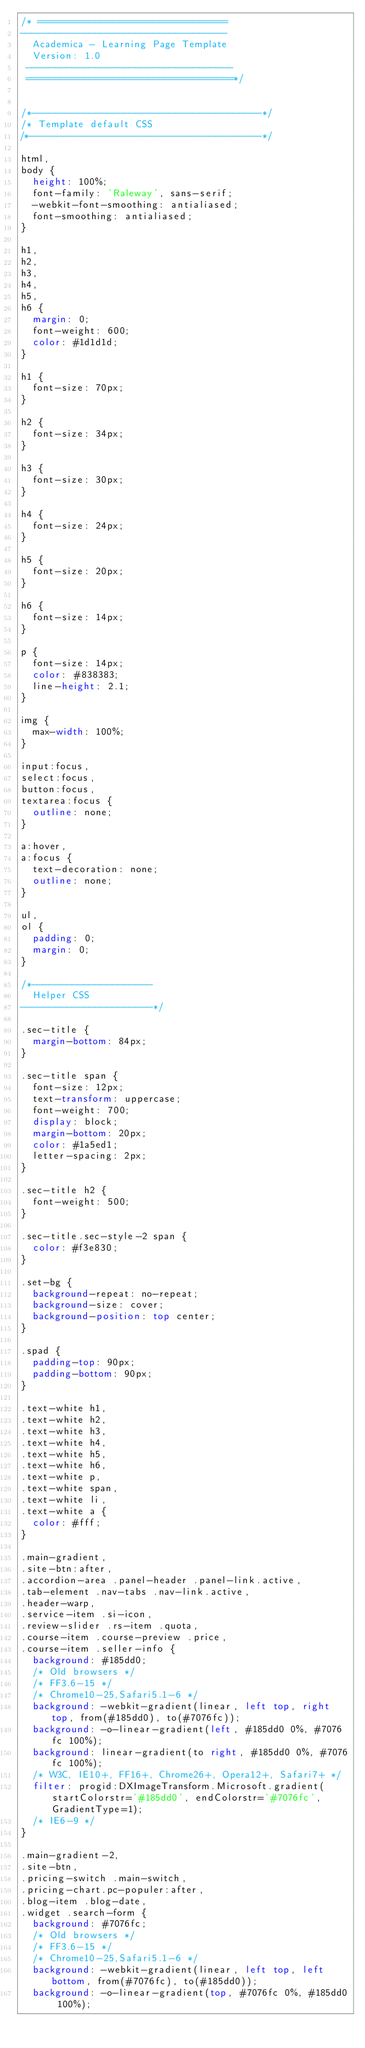<code> <loc_0><loc_0><loc_500><loc_500><_CSS_>/* =================================
------------------------------------
  Academica - Learning Page Template
  Version: 1.0
 ------------------------------------ 
 ====================================*/


/*----------------------------------------*/
/* Template default CSS
/*----------------------------------------*/

html,
body {
	height: 100%;
	font-family: 'Raleway', sans-serif;
	-webkit-font-smoothing: antialiased;
	font-smoothing: antialiased;
}

h1,
h2,
h3,
h4,
h5,
h6 {
	margin: 0;
	font-weight: 600;
	color: #1d1d1d;
}

h1 {
	font-size: 70px;
}

h2 {
	font-size: 34px;
}

h3 {
	font-size: 30px;
}

h4 {
	font-size: 24px;
}

h5 {
	font-size: 20px;
}

h6 {
	font-size: 14px;
}

p {
	font-size: 14px;
	color: #838383;
	line-height: 2.1;
}

img {
	max-width: 100%;
}

input:focus,
select:focus,
button:focus,
textarea:focus {
	outline: none;
}

a:hover,
a:focus {
	text-decoration: none;
	outline: none;
}

ul,
ol {
	padding: 0;
	margin: 0;
}

/*---------------------
	Helper CSS
-----------------------*/

.sec-title {
	margin-bottom: 84px;
}

.sec-title span {
	font-size: 12px;
	text-transform: uppercase;
	font-weight: 700;
	display: block;
	margin-bottom: 20px;
	color: #1a5ed1;
	letter-spacing: 2px;
}

.sec-title h2 {
	font-weight: 500;
}

.sec-title.sec-style-2 span {
	color: #f3e830;
}

.set-bg {
	background-repeat: no-repeat;
	background-size: cover;
	background-position: top center;
}

.spad {
	padding-top: 90px;
	padding-bottom: 90px;
}

.text-white h1,
.text-white h2,
.text-white h3,
.text-white h4,
.text-white h5,
.text-white h6,
.text-white p,
.text-white span,
.text-white li,
.text-white a {
	color: #fff;
}

.main-gradient,
.site-btn:after,
.accordion-area .panel-header .panel-link.active,
.tab-element .nav-tabs .nav-link.active,
.header-warp,
.service-item .si-icon,
.review-slider .rs-item .quota,
.course-item .course-preview .price,
.course-item .seller-info {
	background: #185dd0;
	/* Old browsers */
	/* FF3.6-15 */
	/* Chrome10-25,Safari5.1-6 */
	background: -webkit-gradient(linear, left top, right top, from(#185dd0), to(#7076fc));
	background: -o-linear-gradient(left, #185dd0 0%, #7076fc 100%);
	background: linear-gradient(to right, #185dd0 0%, #7076fc 100%);
	/* W3C, IE10+, FF16+, Chrome26+, Opera12+, Safari7+ */
	filter: progid:DXImageTransform.Microsoft.gradient( startColorstr='#185dd0', endColorstr='#7076fc', GradientType=1);
	/* IE6-9 */
}

.main-gradient-2,
.site-btn,
.pricing-switch .main-switch,
.pricing-chart.pc-populer:after,
.blog-item .blog-date,
.widget .search-form {
	background: #7076fc;
	/* Old browsers */
	/* FF3.6-15 */
	/* Chrome10-25,Safari5.1-6 */
	background: -webkit-gradient(linear, left top, left bottom, from(#7076fc), to(#185dd0));
	background: -o-linear-gradient(top, #7076fc 0%, #185dd0 100%);</code> 